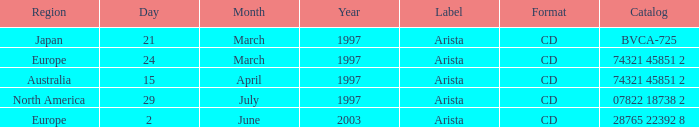What Date has the Region Europe and a Catalog of 74321 45851 2? 24 March 1997. 